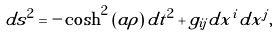Convert formula to latex. <formula><loc_0><loc_0><loc_500><loc_500>d s ^ { 2 } = - \cosh ^ { 2 } \left ( a \rho \right ) d t ^ { 2 } + g _ { i j } d x ^ { i } d x ^ { j } ,</formula> 